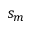<formula> <loc_0><loc_0><loc_500><loc_500>s _ { m }</formula> 